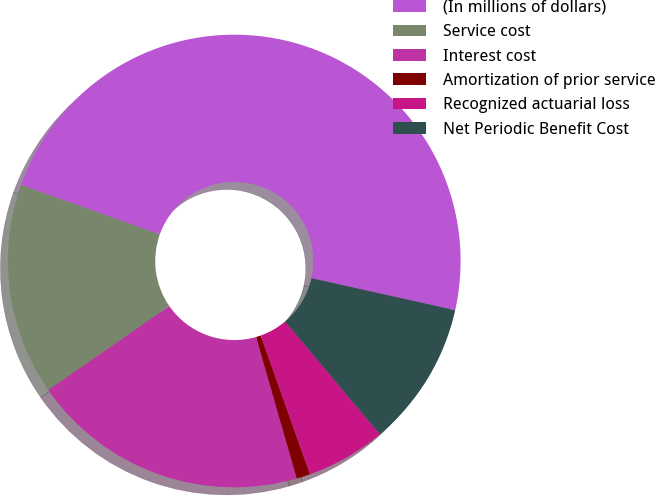<chart> <loc_0><loc_0><loc_500><loc_500><pie_chart><fcel>(In millions of dollars)<fcel>Service cost<fcel>Interest cost<fcel>Amortization of prior service<fcel>Recognized actuarial loss<fcel>Net Periodic Benefit Cost<nl><fcel>48.04%<fcel>15.1%<fcel>19.8%<fcel>0.98%<fcel>5.69%<fcel>10.39%<nl></chart> 